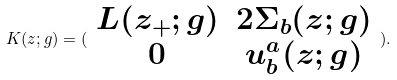<formula> <loc_0><loc_0><loc_500><loc_500>K ( z ; g ) = ( \begin{array} { c c } L ( z _ { + } ; g ) & 2 \Sigma _ { b } ( z ; g ) \\ 0 & u _ { b } ^ { a } ( z ; g ) \end{array} ) .</formula> 